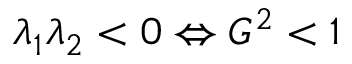<formula> <loc_0><loc_0><loc_500><loc_500>\lambda _ { 1 } \lambda _ { 2 } < 0 \Leftrightarrow G ^ { 2 } < 1</formula> 